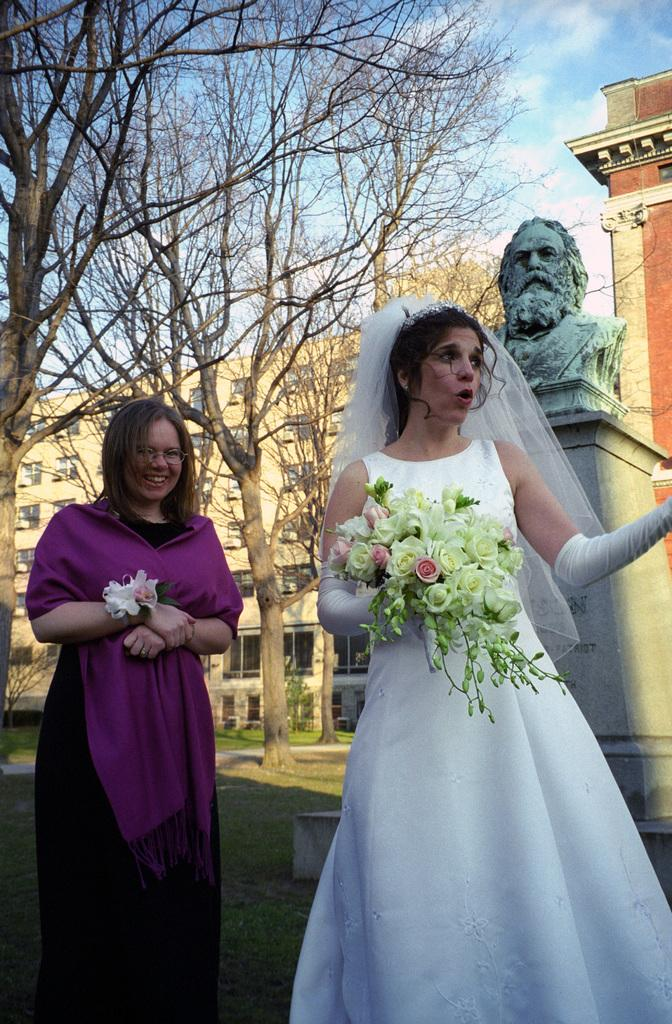How many people are in the image? There are two persons standing in the image. What are the persons holding in the image? The persons are holding flowers. What can be seen in the background of the image? There is a statue with a pillar, trees, grass, buildings, and the sky visible in the background of the image. What type of knee support is visible in the image? There is no knee support present in the image. What kind of lunch is being prepared by the persons in the image? There is no lunch preparation or consumption depicted in the image. 